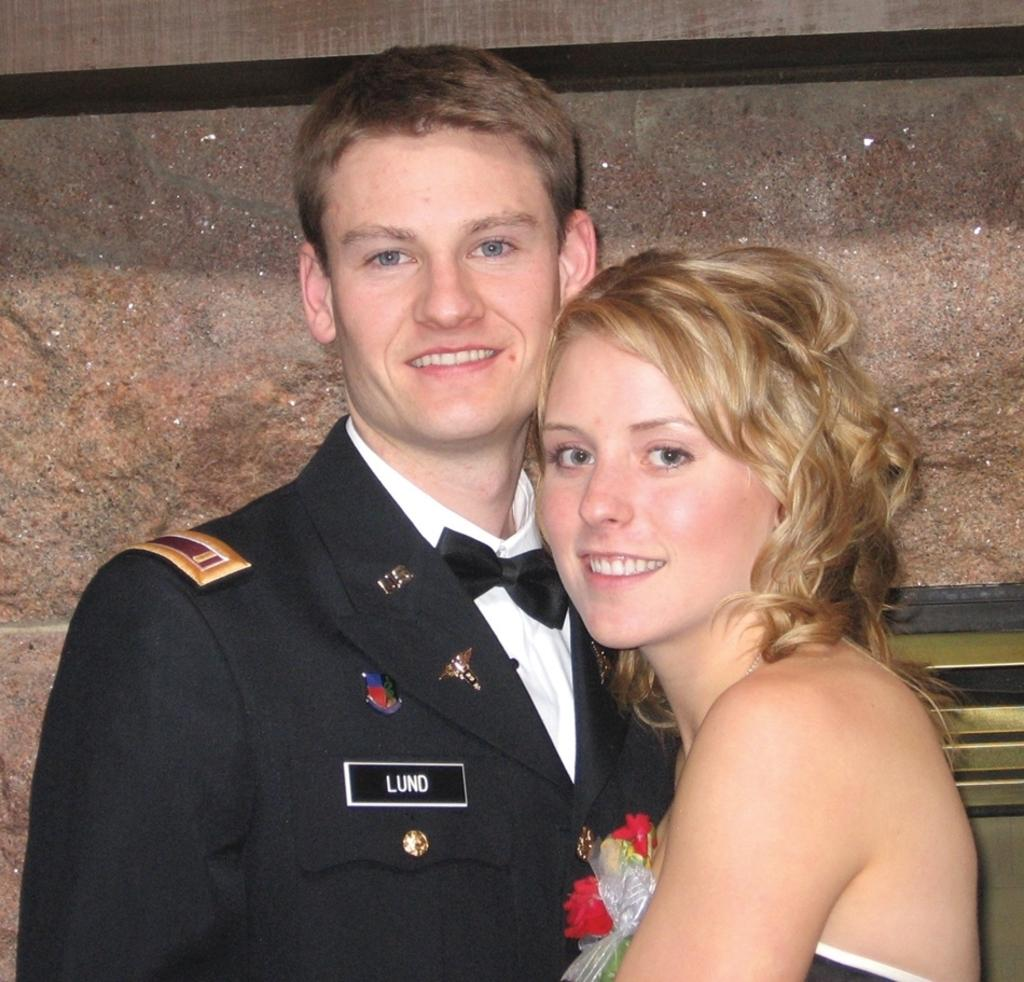What is the person in the image wearing? The person in the image is wearing a suit. What is the facial expression of the person in the image? The person is smiling. What is the person in the image doing? The person is standing. Can you describe the woman in the image? The woman is also in the image, and she is smiling and standing. What is visible in the background of the image? There is a wall in the background of the image. What type of honey can be seen in the image? There is no honey present in the image. How many drawers are visible in the image? There are no drawers visible in the image. 